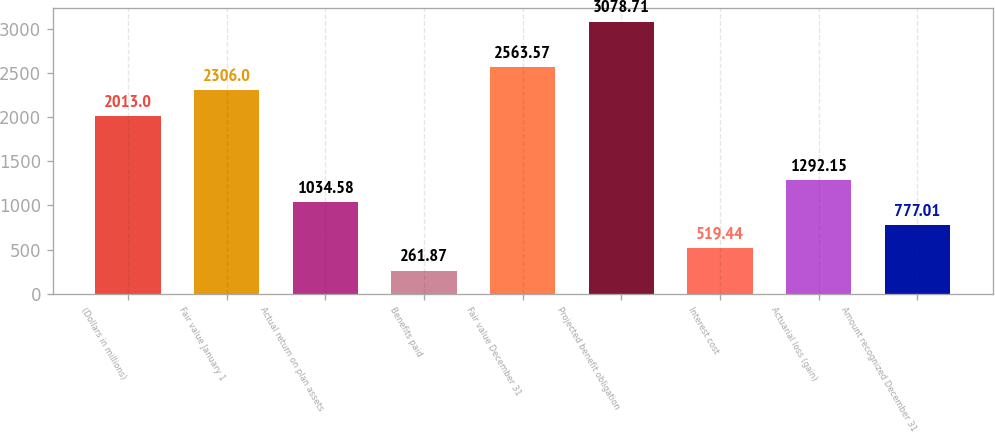<chart> <loc_0><loc_0><loc_500><loc_500><bar_chart><fcel>(Dollars in millions)<fcel>Fair value January 1<fcel>Actual return on plan assets<fcel>Benefits paid<fcel>Fair value December 31<fcel>Projected benefit obligation<fcel>Interest cost<fcel>Actuarial loss (gain)<fcel>Amount recognized December 31<nl><fcel>2013<fcel>2306<fcel>1034.58<fcel>261.87<fcel>2563.57<fcel>3078.71<fcel>519.44<fcel>1292.15<fcel>777.01<nl></chart> 